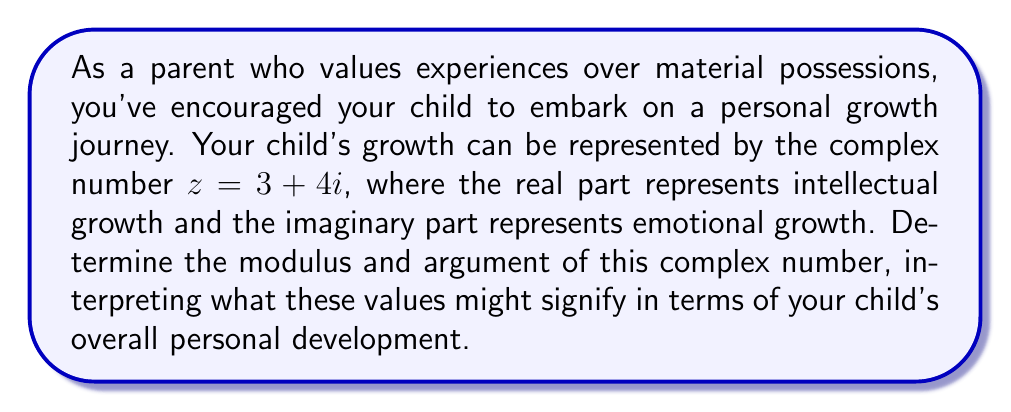Could you help me with this problem? To solve this problem, we need to calculate the modulus and argument of the complex number $z = 3 + 4i$.

1. Modulus:
The modulus of a complex number $z = a + bi$ is given by the formula:

$$|z| = \sqrt{a^2 + b^2}$$

In this case, $a = 3$ and $b = 4$. So:

$$|z| = \sqrt{3^2 + 4^2} = \sqrt{9 + 16} = \sqrt{25} = 5$$

The modulus represents the magnitude of the complex number, which in this context could be interpreted as the overall extent of personal growth.

2. Argument:
The argument of a complex number is the angle it makes with the positive real axis. It can be calculated using the arctangent function:

$$\arg(z) = \tan^{-1}\left(\frac{b}{a}\right)$$

However, we need to be careful about which quadrant the complex number is in. In this case, both $a$ and $b$ are positive, so $z$ is in the first quadrant, and we can use the formula directly:

$$\arg(z) = \tan^{-1}\left(\frac{4}{3}\right) \approx 0.9273 \text{ radians}$$

To convert to degrees:

$$0.9273 \text{ radians} \times \frac{180°}{\pi} \approx 53.13°$$

The argument represents the balance between intellectual and emotional growth. An angle of 45° would represent equal growth in both areas, so this result suggests slightly more emphasis on emotional growth.

[asy]
import graph;
size(200);
real x = 3, y = 4;
draw((-1,0)--(5,0), arrow=Arrow);
draw((0,-1)--(0,5), arrow=Arrow);
draw((0,0)--(x,y), arrow=Arrow, red);
draw(arc((0,0), 0.8, 0, degrees(atan2(y,x))), blue);
label("Re", (5,0), E);
label("Im", (0,5), N);
label("$z$", (x,y), NE);
label("$\theta$", (0.4,0.3), NW);
dot((x,y));
[/asy]
Answer: Modulus: $|z| = 5$
Argument: $\arg(z) \approx 0.9273 \text{ radians} \approx 53.13°$

Interpretation: The modulus of 5 represents significant overall personal growth. The argument of approximately 53.13° indicates a balanced growth with a slightly higher emphasis on emotional development compared to intellectual growth. 